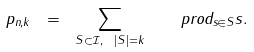Convert formula to latex. <formula><loc_0><loc_0><loc_500><loc_500>p _ { n , k } \ = \ \sum _ { S \subset \mathcal { I } , \ | S | = k } \ \ \ p r o d _ { s \in S } s .</formula> 